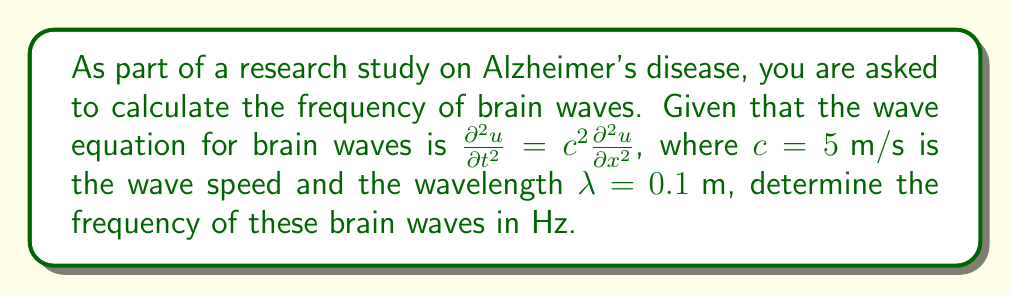Solve this math problem. To calculate the frequency of brain waves using the wave equation, we'll follow these steps:

1) The general form of the wave equation is:

   $$\frac{\partial^2 u}{\partial t^2} = c^2 \frac{\partial^2 u}{\partial x^2}$$

2) We know that for any wave, the relationship between wave speed ($c$), wavelength ($\lambda$), and frequency ($f$) is:

   $$c = \lambda f$$

3) We are given:
   $c = 5 \text{ m/s}$
   $\lambda = 0.1 \text{ m}$

4) Rearranging the wave speed equation to solve for frequency:

   $$f = \frac{c}{\lambda}$$

5) Substituting the known values:

   $$f = \frac{5 \text{ m/s}}{0.1 \text{ m}}$$

6) Calculating:

   $$f = 50 \text{ Hz}$$

Therefore, the frequency of the brain waves is 50 Hz.
Answer: 50 Hz 